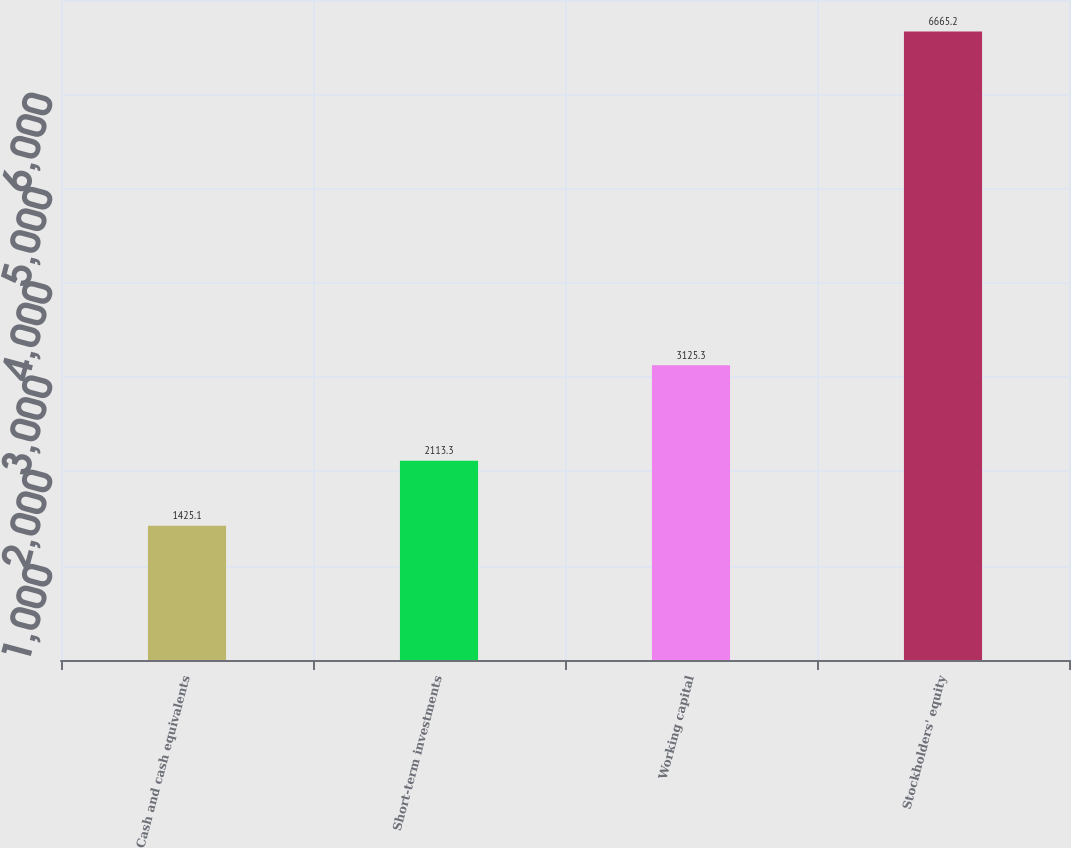<chart> <loc_0><loc_0><loc_500><loc_500><bar_chart><fcel>Cash and cash equivalents<fcel>Short-term investments<fcel>Working capital<fcel>Stockholders' equity<nl><fcel>1425.1<fcel>2113.3<fcel>3125.3<fcel>6665.2<nl></chart> 